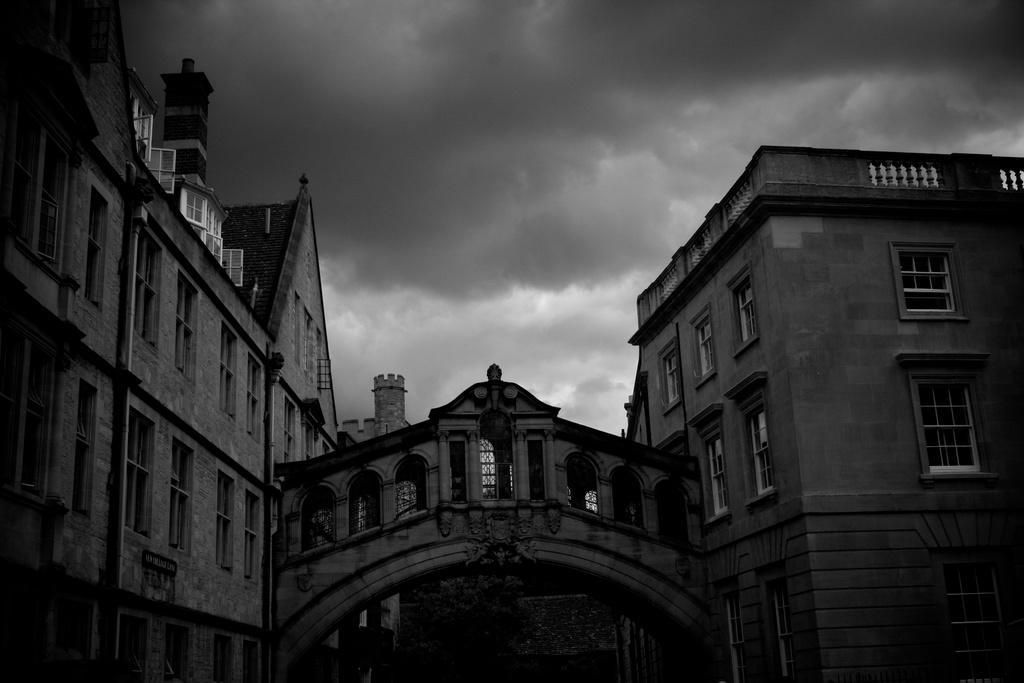Please provide a concise description of this image. In this image we can see there is a big building along with connecting bridge in between. 